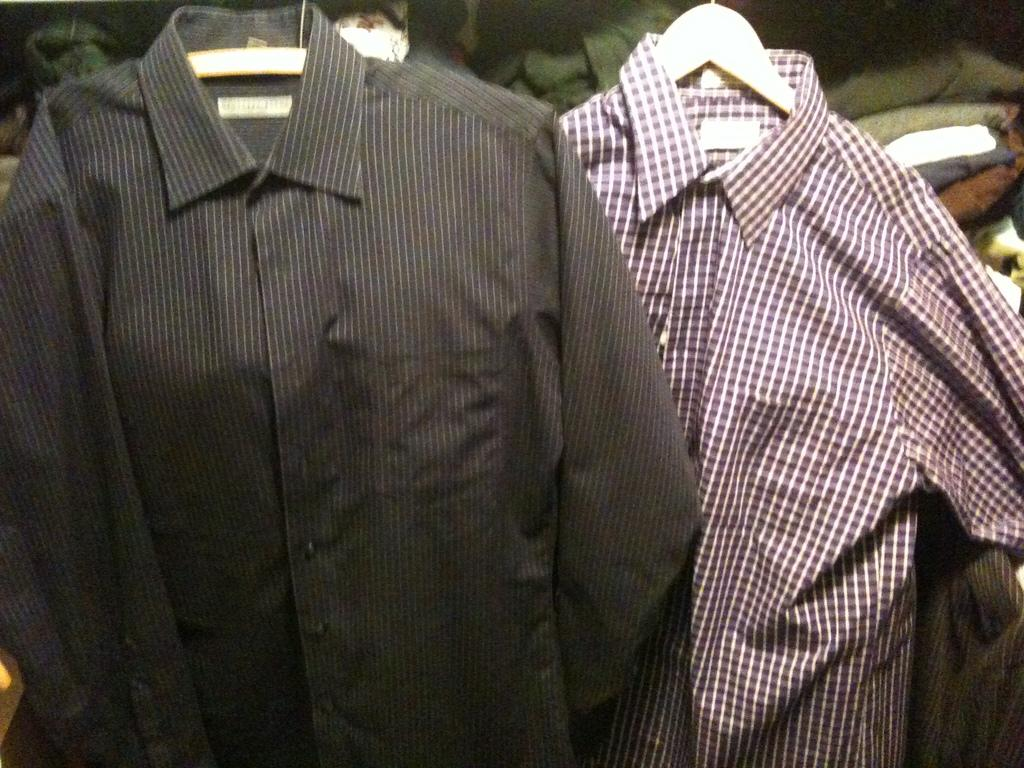What can be seen hanging in the image? There are two sheets on hangers in the image. Can you describe any other clothes visible in the image? There are more clothes visible in the background of the image. What type of mountain can be seen in the background of the image? There is no mountain visible in the image; it only features sheets and other clothes. Can you tell me how many guitars are leaning against the wall in the image? There are no guitars present in the image. 